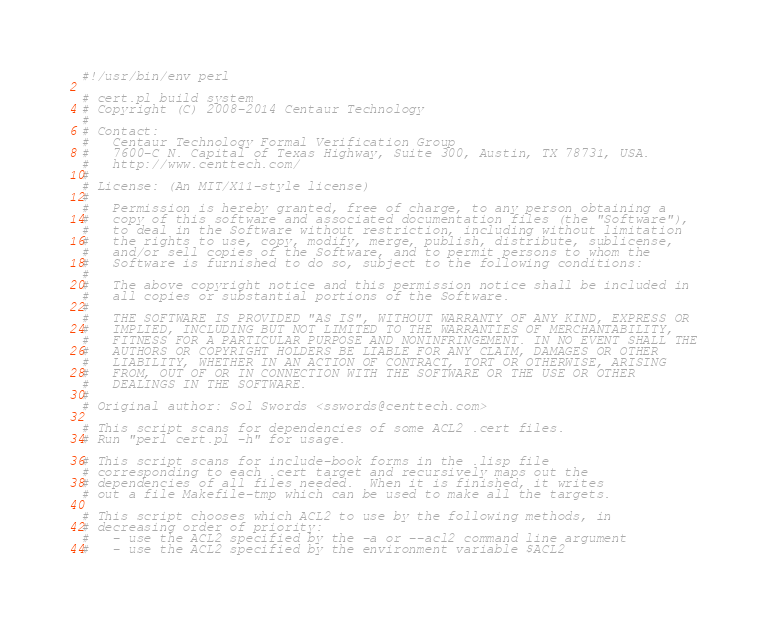<code> <loc_0><loc_0><loc_500><loc_500><_Perl_>#!/usr/bin/env perl

# cert.pl build system
# Copyright (C) 2008-2014 Centaur Technology
#
# Contact:
#   Centaur Technology Formal Verification Group
#   7600-C N. Capital of Texas Highway, Suite 300, Austin, TX 78731, USA.
#   http://www.centtech.com/
#
# License: (An MIT/X11-style license)
#
#   Permission is hereby granted, free of charge, to any person obtaining a
#   copy of this software and associated documentation files (the "Software"),
#   to deal in the Software without restriction, including without limitation
#   the rights to use, copy, modify, merge, publish, distribute, sublicense,
#   and/or sell copies of the Software, and to permit persons to whom the
#   Software is furnished to do so, subject to the following conditions:
#
#   The above copyright notice and this permission notice shall be included in
#   all copies or substantial portions of the Software.
#
#   THE SOFTWARE IS PROVIDED "AS IS", WITHOUT WARRANTY OF ANY KIND, EXPRESS OR
#   IMPLIED, INCLUDING BUT NOT LIMITED TO THE WARRANTIES OF MERCHANTABILITY,
#   FITNESS FOR A PARTICULAR PURPOSE AND NONINFRINGEMENT. IN NO EVENT SHALL THE
#   AUTHORS OR COPYRIGHT HOLDERS BE LIABLE FOR ANY CLAIM, DAMAGES OR OTHER
#   LIABILITY, WHETHER IN AN ACTION OF CONTRACT, TORT OR OTHERWISE, ARISING
#   FROM, OUT OF OR IN CONNECTION WITH THE SOFTWARE OR THE USE OR OTHER
#   DEALINGS IN THE SOFTWARE.
#
# Original author: Sol Swords <sswords@centtech.com>

# This script scans for dependencies of some ACL2 .cert files.
# Run "perl cert.pl -h" for usage.

# This script scans for include-book forms in the .lisp file
# corresponding to each .cert target and recursively maps out the
# dependencies of all files needed.  When it is finished, it writes
# out a file Makefile-tmp which can be used to make all the targets.

# This script chooses which ACL2 to use by the following methods, in
# decreasing order of priority:
#   - use the ACL2 specified by the -a or --acl2 command line argument
#   - use the ACL2 specified by the environment variable $ACL2</code> 